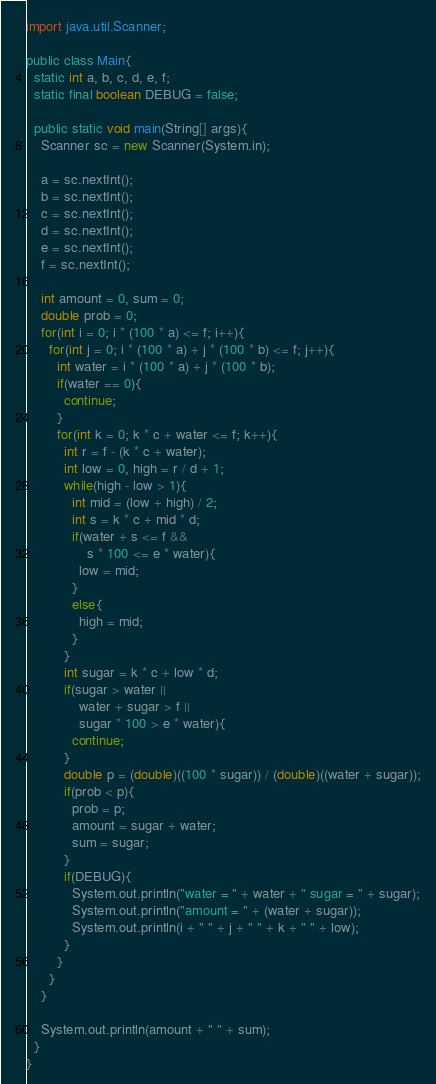<code> <loc_0><loc_0><loc_500><loc_500><_Java_>import java.util.Scanner;

public class Main{
  static int a, b, c, d, e, f;
  static final boolean DEBUG = false;

  public static void main(String[] args){
    Scanner sc = new Scanner(System.in);

    a = sc.nextInt();
    b = sc.nextInt();
    c = sc.nextInt();
    d = sc.nextInt();
    e = sc.nextInt();
    f = sc.nextInt();

    int amount = 0, sum = 0;
    double prob = 0;
    for(int i = 0; i * (100 * a) <= f; i++){
      for(int j = 0; i * (100 * a) + j * (100 * b) <= f; j++){
        int water = i * (100 * a) + j * (100 * b);
        if(water == 0){
          continue;
        }
        for(int k = 0; k * c + water <= f; k++){
          int r = f - (k * c + water);
          int low = 0, high = r / d + 1;
          while(high - low > 1){
            int mid = (low + high) / 2;
            int s = k * c + mid * d;
            if(water + s <= f && 
                s * 100 <= e * water){
              low = mid;
            }
            else{
              high = mid;
            }
          }
          int sugar = k * c + low * d;
          if(sugar > water || 
              water + sugar > f ||
              sugar * 100 > e * water){
            continue;
          }
          double p = (double)((100 * sugar)) / (double)((water + sugar));
          if(prob < p){
            prob = p;
            amount = sugar + water;
            sum = sugar;
          }
          if(DEBUG){
            System.out.println("water = " + water + " sugar = " + sugar);
            System.out.println("amount = " + (water + sugar));
            System.out.println(i + " " + j + " " + k + " " + low);
          }
        }
      }
    }

    System.out.println(amount + " " + sum);
  }
}
</code> 